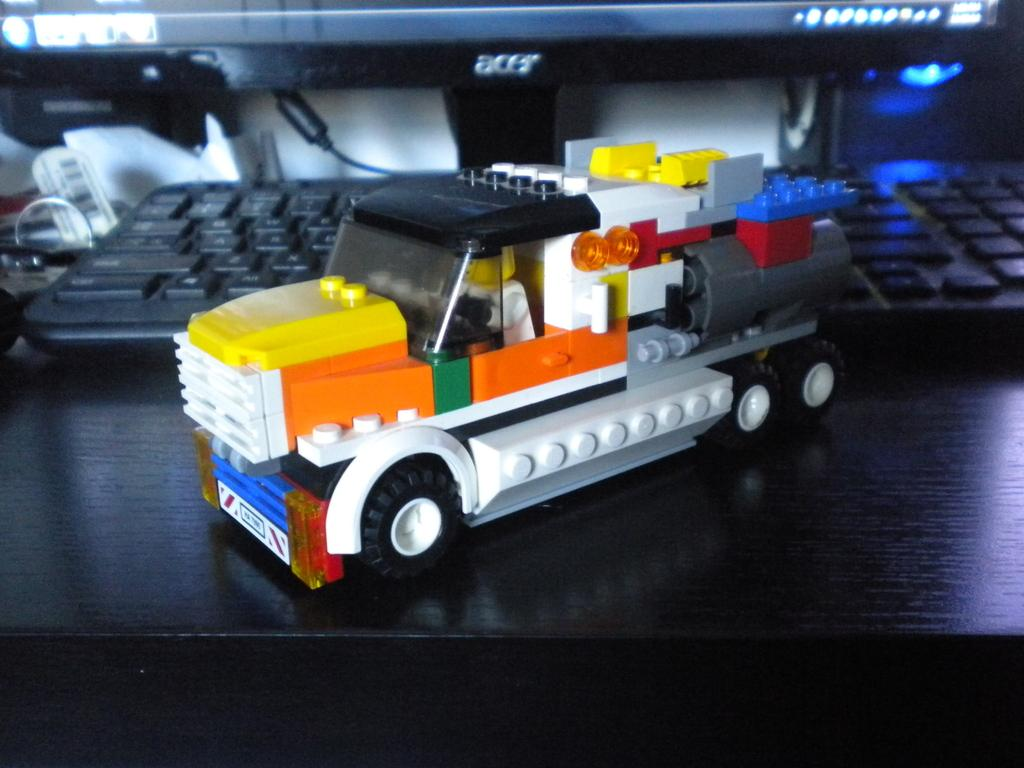What object is placed on the table in the image? There is a toy truck on a table. What type of electronic device is present in the image? There is a black color keyboard in the image. Can you describe the position of the monitor in the image? There is a monitor at the back in the image. What type of picture is hanging on the wall behind the monitor? There is no picture hanging on the wall behind the monitor in the image. What kind of surprise can be seen in the image? There is no surprise present in the image. 